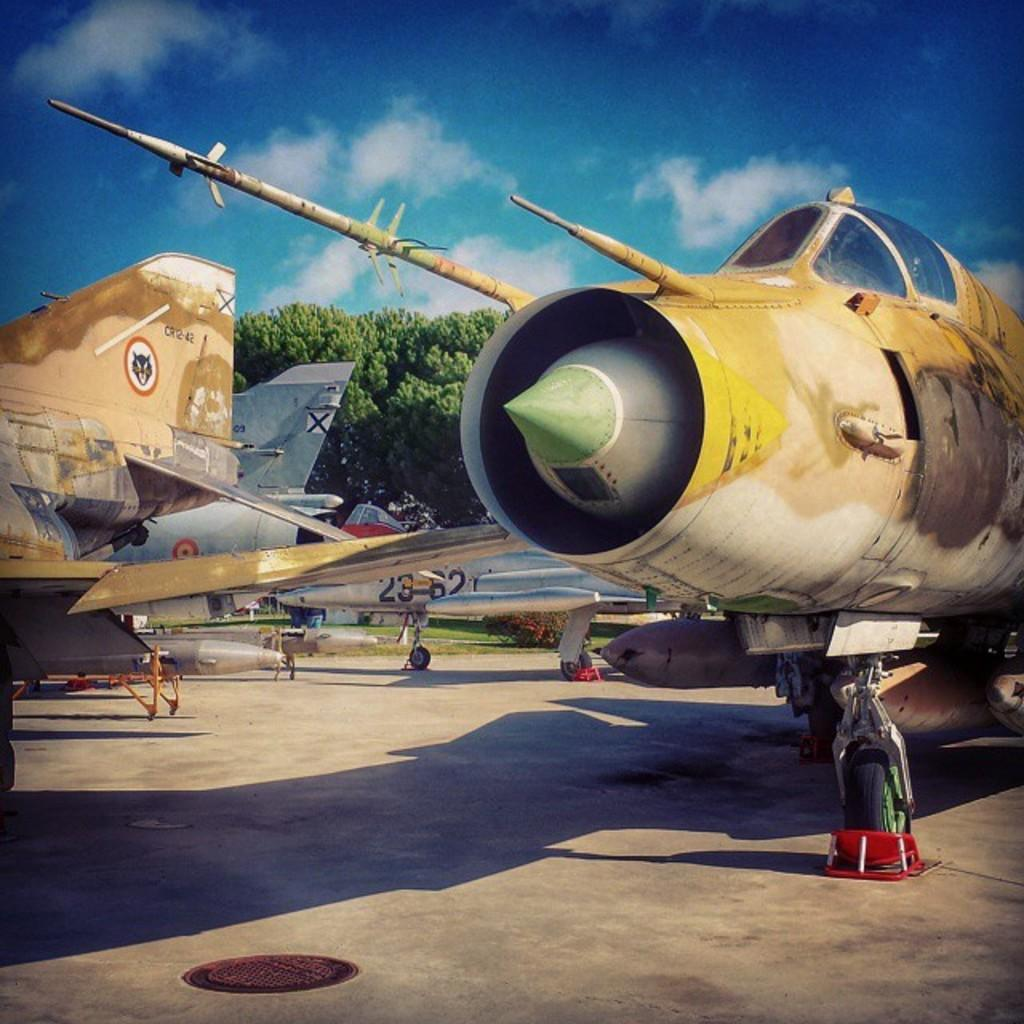What is the main subject of the image? The main subject of the image is airplanes. What other elements can be seen in the image besides airplanes? There are trees and the sky visible in the image. What type of scent can be detected from the trees in the image? There is no information about the scent of the trees in the image, as we are only given visual information. 